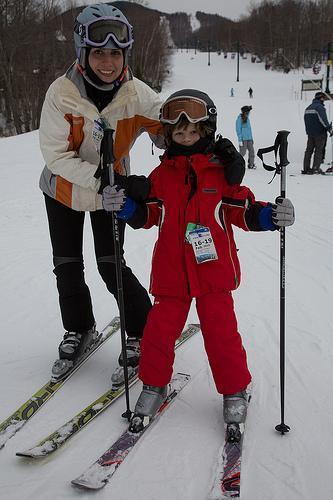How many people are posing?
Give a very brief answer. 2. 